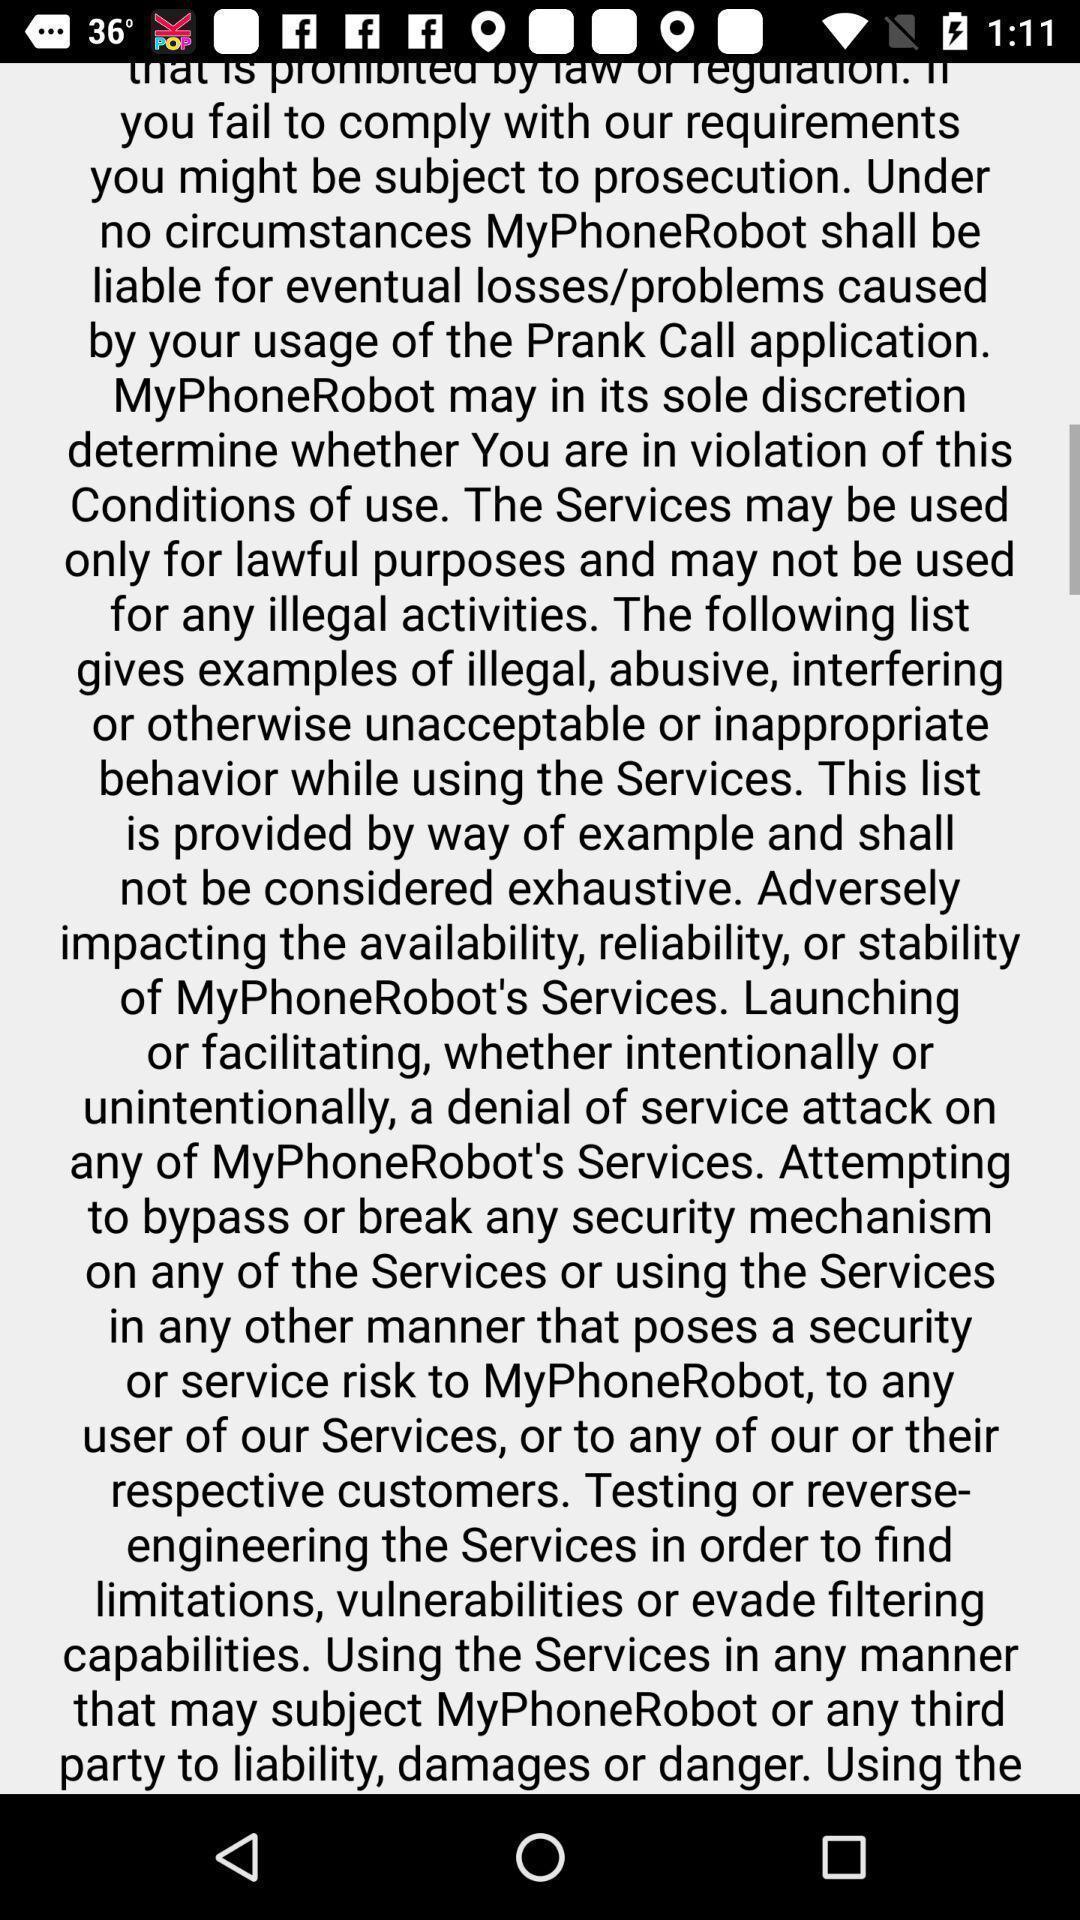Provide a detailed account of this screenshot. Screen page displaying an information. 